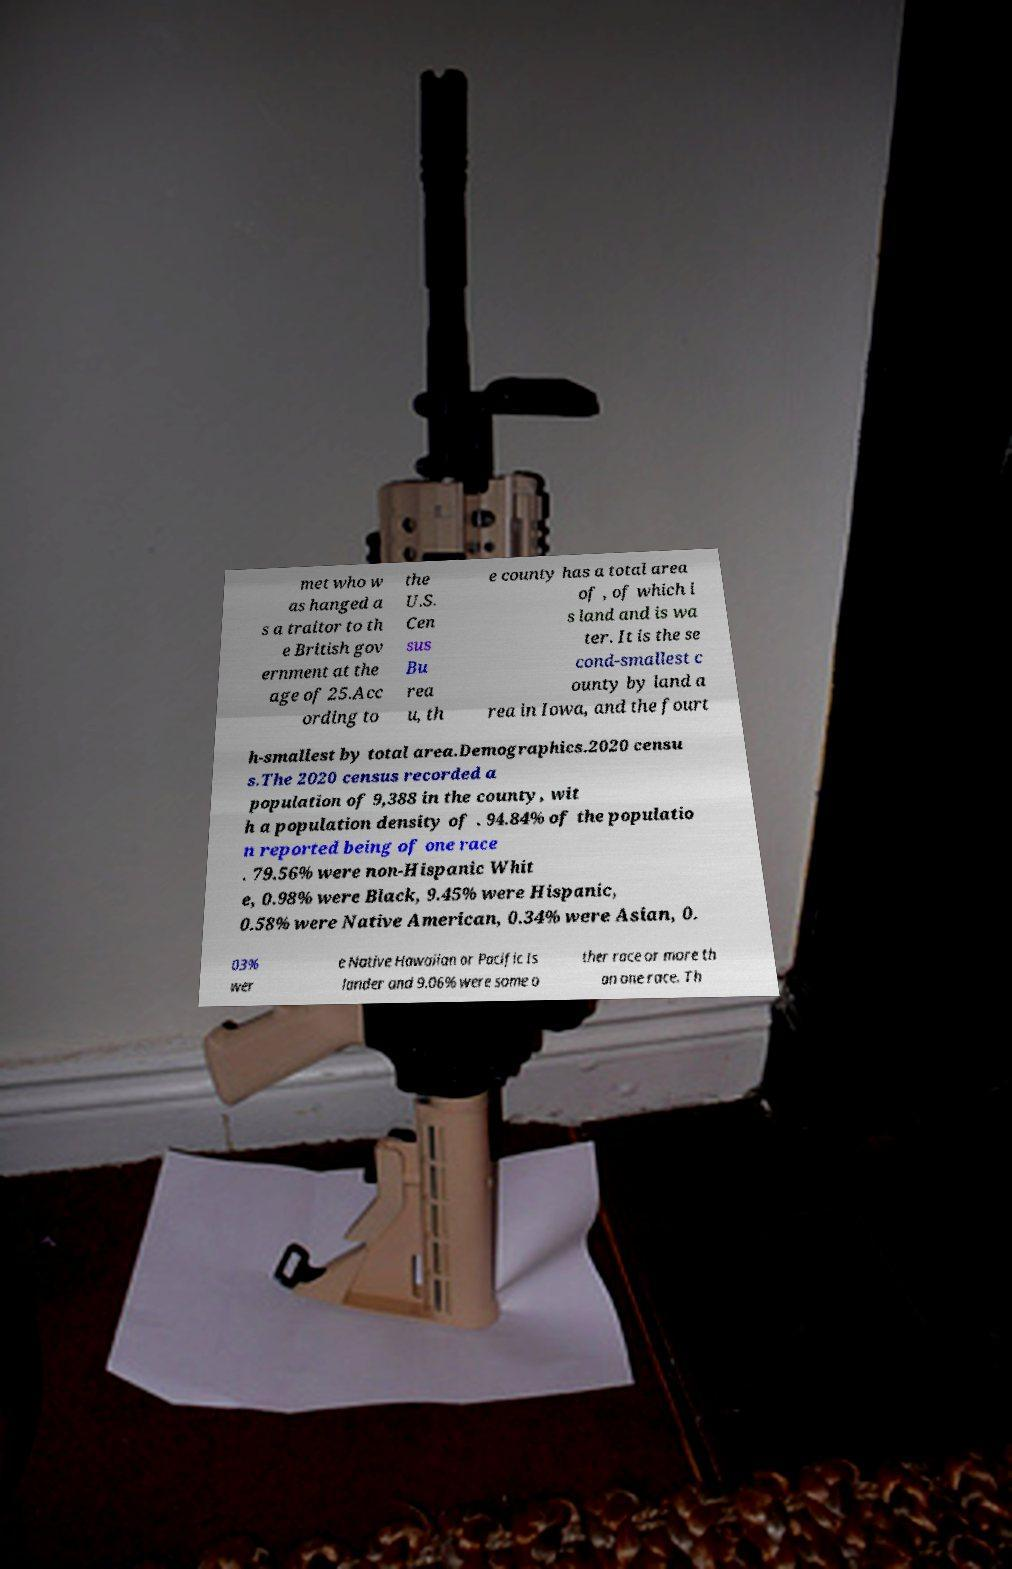For documentation purposes, I need the text within this image transcribed. Could you provide that? met who w as hanged a s a traitor to th e British gov ernment at the age of 25.Acc ording to the U.S. Cen sus Bu rea u, th e county has a total area of , of which i s land and is wa ter. It is the se cond-smallest c ounty by land a rea in Iowa, and the fourt h-smallest by total area.Demographics.2020 censu s.The 2020 census recorded a population of 9,388 in the county, wit h a population density of . 94.84% of the populatio n reported being of one race . 79.56% were non-Hispanic Whit e, 0.98% were Black, 9.45% were Hispanic, 0.58% were Native American, 0.34% were Asian, 0. 03% wer e Native Hawaiian or Pacific Is lander and 9.06% were some o ther race or more th an one race. Th 